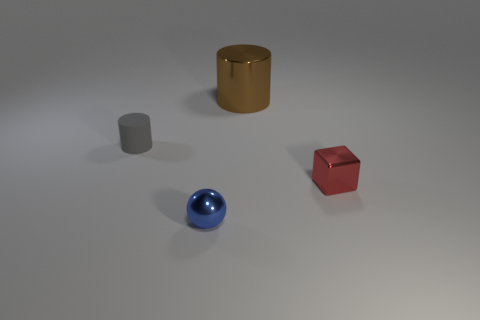Add 1 small blue balls. How many objects exist? 5 Subtract all blocks. How many objects are left? 3 Add 2 big metal objects. How many big metal objects are left? 3 Add 1 small metallic spheres. How many small metallic spheres exist? 2 Subtract 0 purple cylinders. How many objects are left? 4 Subtract all tiny blue metal balls. Subtract all tiny rubber things. How many objects are left? 2 